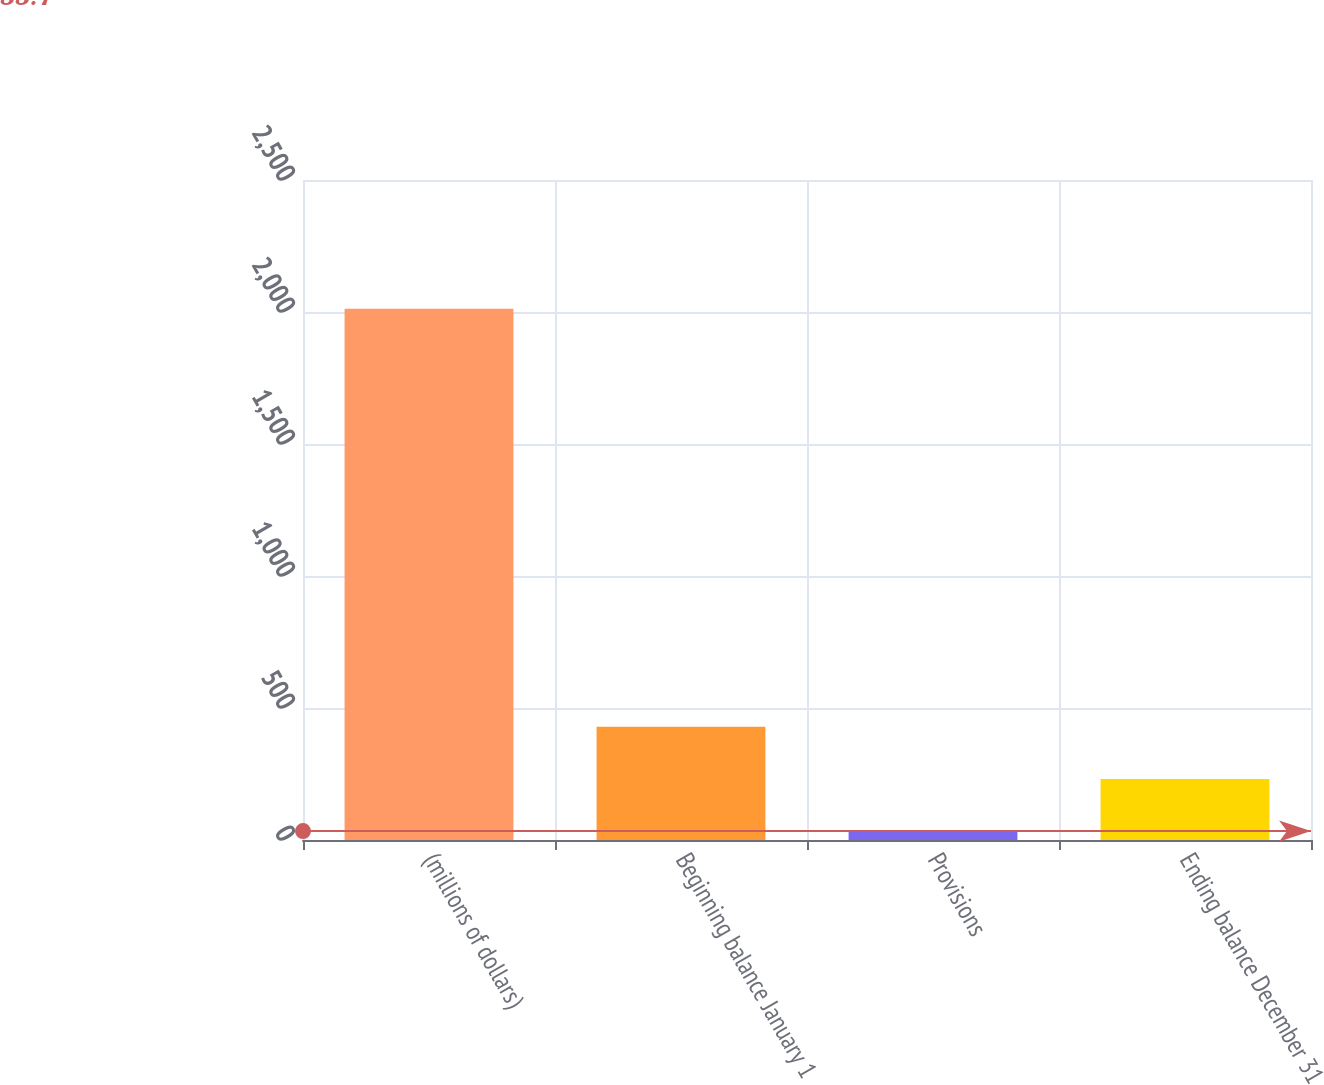<chart> <loc_0><loc_0><loc_500><loc_500><bar_chart><fcel>(millions of dollars)<fcel>Beginning balance January 1<fcel>Provisions<fcel>Ending balance December 31<nl><fcel>2012<fcel>429.36<fcel>33.7<fcel>231.53<nl></chart> 